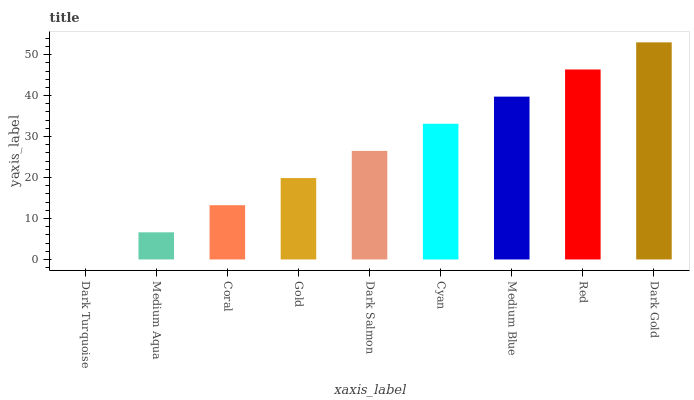Is Dark Turquoise the minimum?
Answer yes or no. Yes. Is Dark Gold the maximum?
Answer yes or no. Yes. Is Medium Aqua the minimum?
Answer yes or no. No. Is Medium Aqua the maximum?
Answer yes or no. No. Is Medium Aqua greater than Dark Turquoise?
Answer yes or no. Yes. Is Dark Turquoise less than Medium Aqua?
Answer yes or no. Yes. Is Dark Turquoise greater than Medium Aqua?
Answer yes or no. No. Is Medium Aqua less than Dark Turquoise?
Answer yes or no. No. Is Dark Salmon the high median?
Answer yes or no. Yes. Is Dark Salmon the low median?
Answer yes or no. Yes. Is Dark Gold the high median?
Answer yes or no. No. Is Dark Gold the low median?
Answer yes or no. No. 